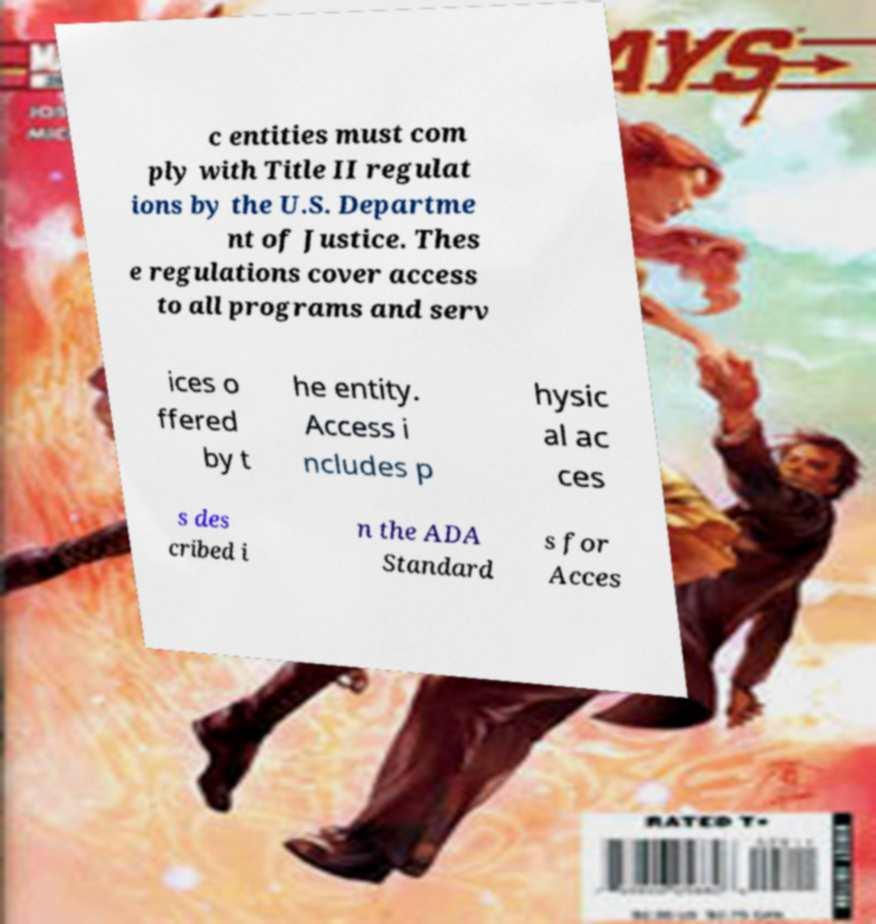There's text embedded in this image that I need extracted. Can you transcribe it verbatim? c entities must com ply with Title II regulat ions by the U.S. Departme nt of Justice. Thes e regulations cover access to all programs and serv ices o ffered by t he entity. Access i ncludes p hysic al ac ces s des cribed i n the ADA Standard s for Acces 